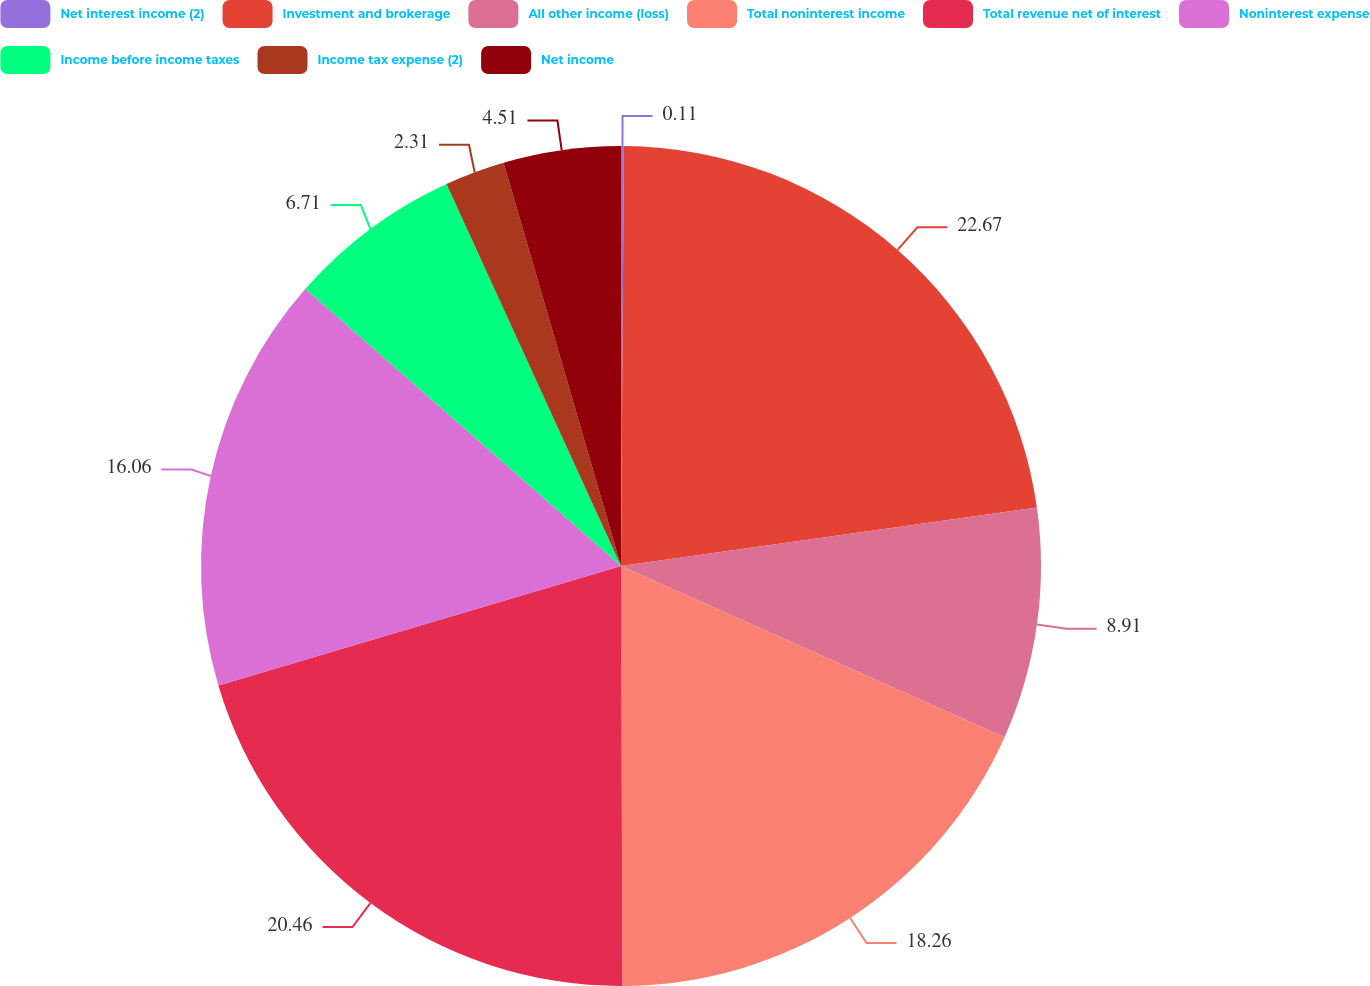<chart> <loc_0><loc_0><loc_500><loc_500><pie_chart><fcel>Net interest income (2)<fcel>Investment and brokerage<fcel>All other income (loss)<fcel>Total noninterest income<fcel>Total revenue net of interest<fcel>Noninterest expense<fcel>Income before income taxes<fcel>Income tax expense (2)<fcel>Net income<nl><fcel>0.11%<fcel>22.66%<fcel>8.91%<fcel>18.26%<fcel>20.46%<fcel>16.06%<fcel>6.71%<fcel>2.31%<fcel>4.51%<nl></chart> 